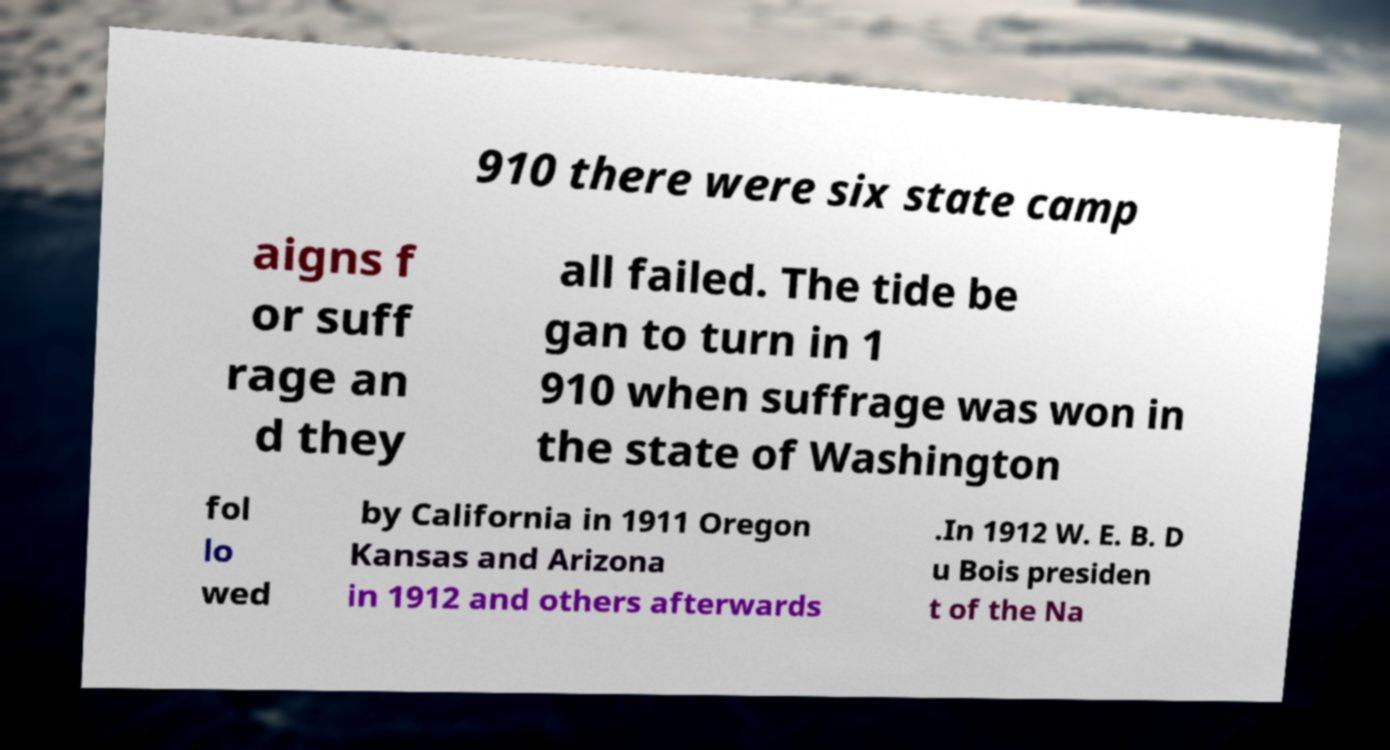There's text embedded in this image that I need extracted. Can you transcribe it verbatim? 910 there were six state camp aigns f or suff rage an d they all failed. The tide be gan to turn in 1 910 when suffrage was won in the state of Washington fol lo wed by California in 1911 Oregon Kansas and Arizona in 1912 and others afterwards .In 1912 W. E. B. D u Bois presiden t of the Na 